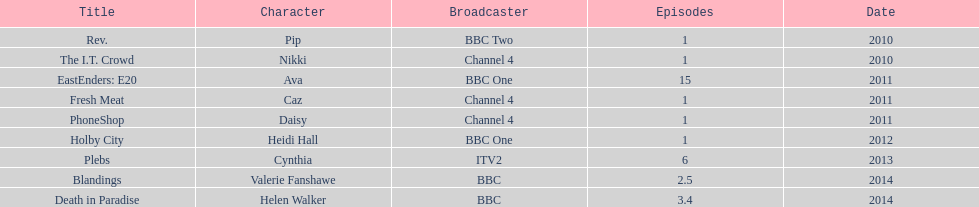How many titles only had one episode? 5. 